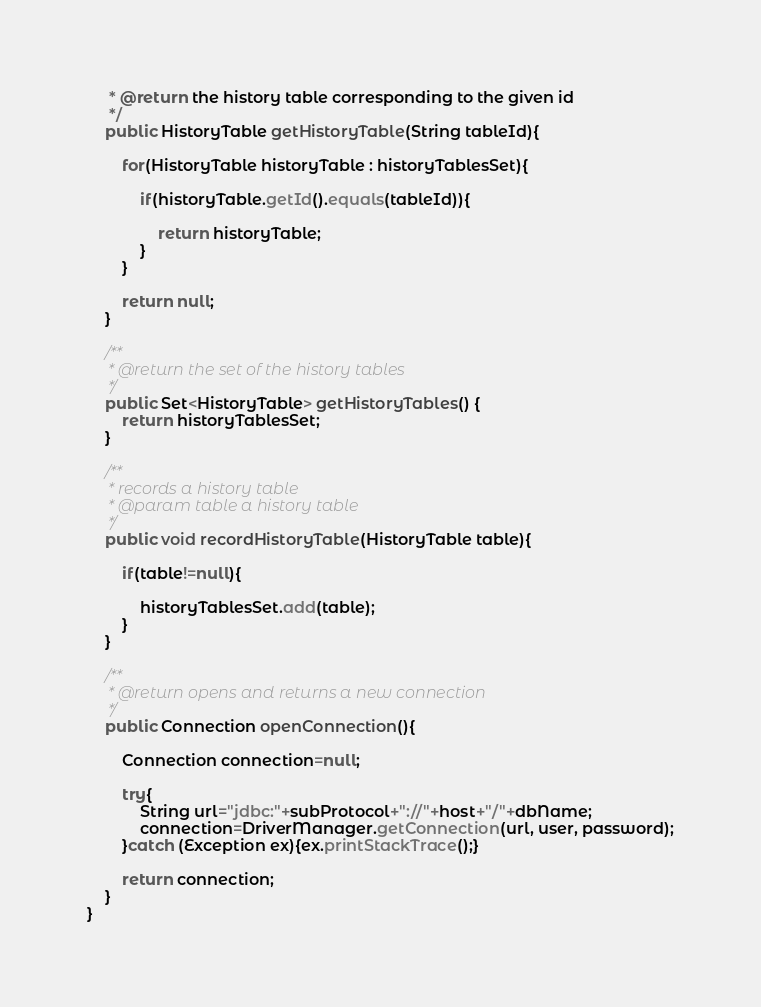Convert code to text. <code><loc_0><loc_0><loc_500><loc_500><_Java_>	 * @return the history table corresponding to the given id
	 */
	public HistoryTable getHistoryTable(String tableId){

		for(HistoryTable historyTable : historyTablesSet){
			
			if(historyTable.getId().equals(tableId)){
				
				return historyTable;
			}
		}
		
		return null;
	}
	
	/**
	 * @return the set of the history tables
	 */
	public Set<HistoryTable> getHistoryTables() {
		return historyTablesSet;
	}
	
	/**
	 * records a history table
	 * @param table a history table
	 */
	public void recordHistoryTable(HistoryTable table){
		
		if(table!=null){
			
			historyTablesSet.add(table);
		}
	}
	
	/**
	 * @return opens and returns a new connection
	 */
	public Connection openConnection(){
		
    	Connection connection=null;
    	
    	try{
    		String url="jdbc:"+subProtocol+"://"+host+"/"+dbName;
        	connection=DriverManager.getConnection(url, user, password);
    	}catch (Exception ex){ex.printStackTrace();}

		return connection;
	}
}
</code> 